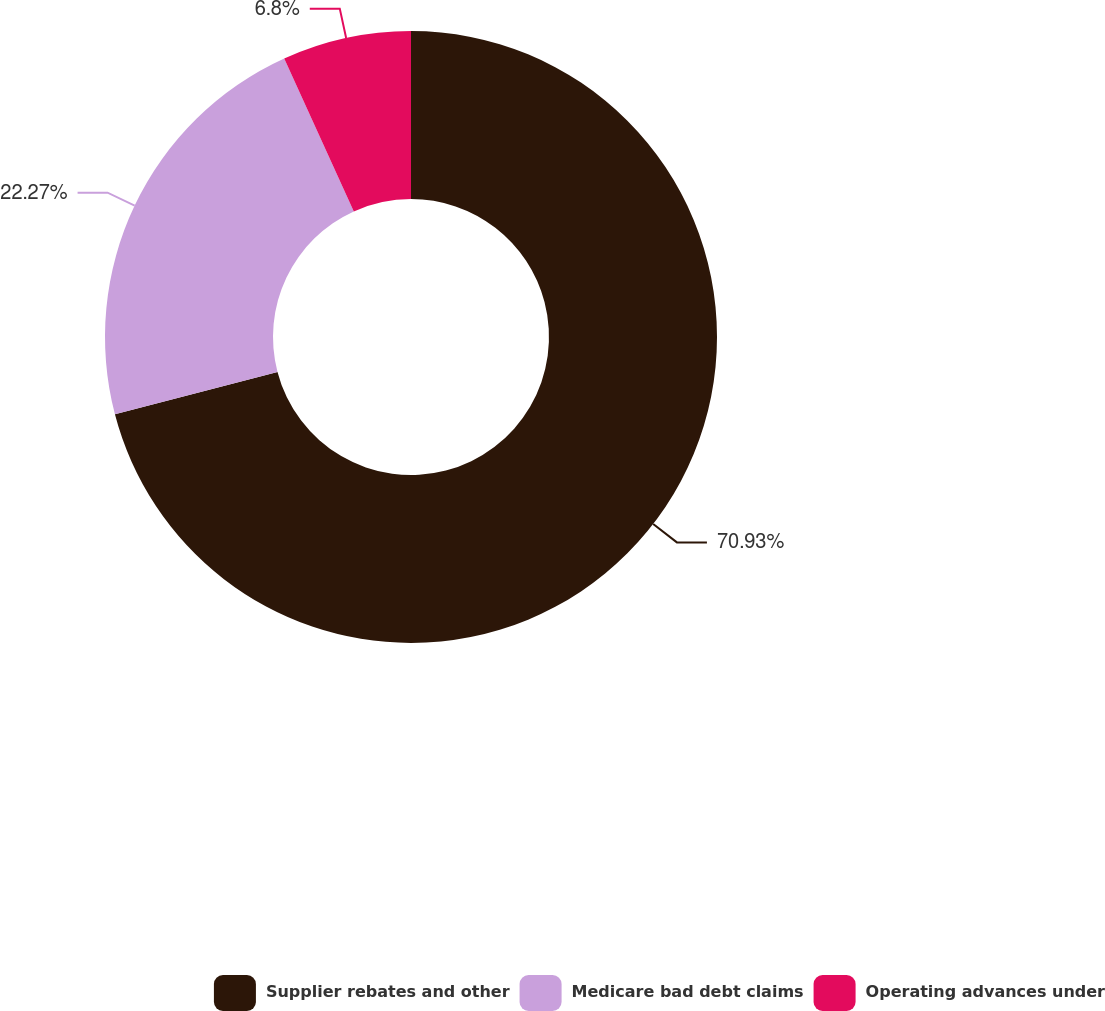Convert chart. <chart><loc_0><loc_0><loc_500><loc_500><pie_chart><fcel>Supplier rebates and other<fcel>Medicare bad debt claims<fcel>Operating advances under<nl><fcel>70.94%<fcel>22.27%<fcel>6.8%<nl></chart> 